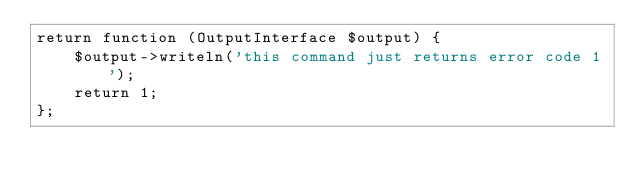<code> <loc_0><loc_0><loc_500><loc_500><_PHP_>return function (OutputInterface $output) {
    $output->writeln('this command just returns error code 1');
    return 1;
};
</code> 